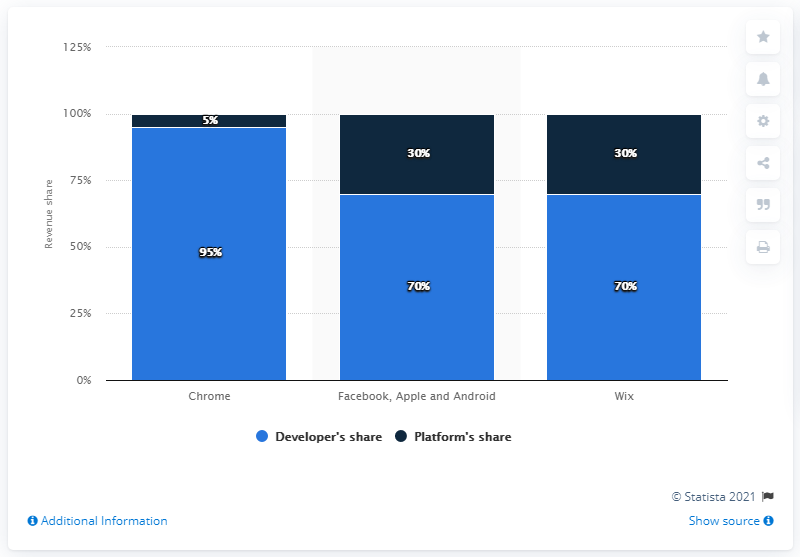Outline some significant characteristics in this image. The typical percentage of revenue that app developers take when designing applications for the Chrome platform is 5%. In general, the app developer typically takes around 95% of the revenue when designing applications for the Chrome platform. 